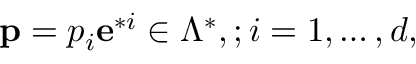Convert formula to latex. <formula><loc_0><loc_0><loc_500><loc_500>{ p } = p _ { i } { e } ^ { * i } \in \Lambda ^ { * } , ; i = 1 , \dots , d ,</formula> 